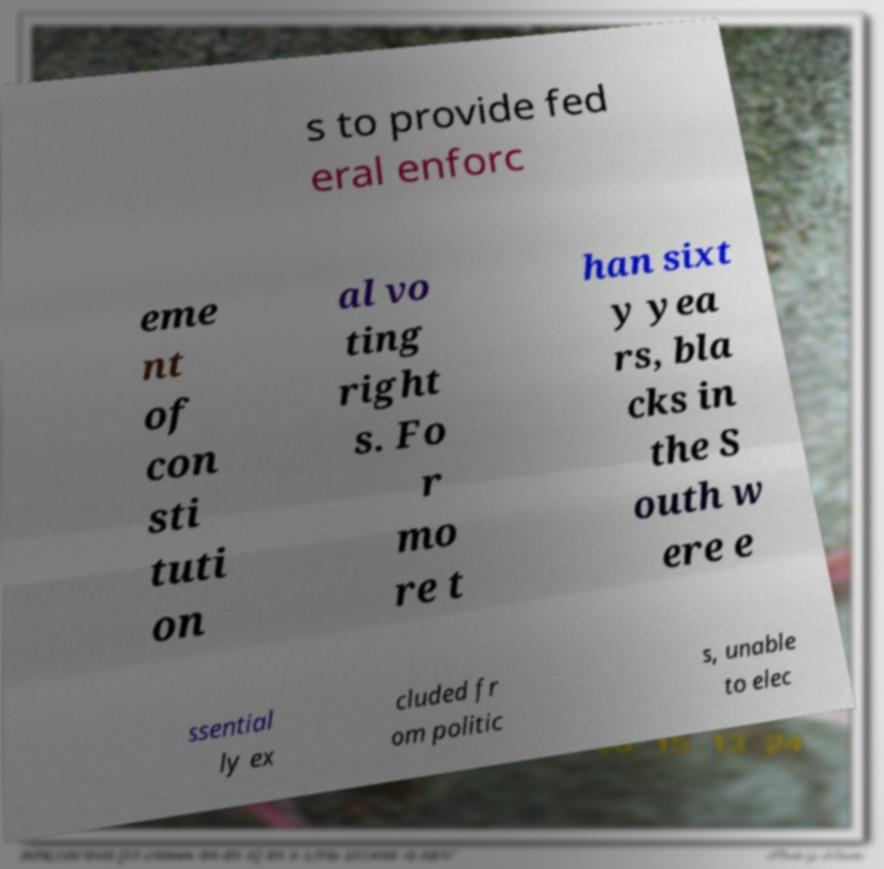Can you read and provide the text displayed in the image?This photo seems to have some interesting text. Can you extract and type it out for me? s to provide fed eral enforc eme nt of con sti tuti on al vo ting right s. Fo r mo re t han sixt y yea rs, bla cks in the S outh w ere e ssential ly ex cluded fr om politic s, unable to elec 